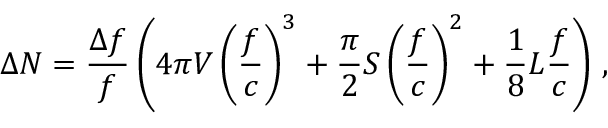<formula> <loc_0><loc_0><loc_500><loc_500>\Delta N = \frac { \Delta f } { f } \left ( 4 \pi V \left ( \frac { f } { c } \right ) ^ { 3 } + \frac { \pi } { 2 } S \left ( \frac { f } { c } \right ) ^ { 2 } + \frac { 1 } { 8 } L \frac { f } { c } \right ) \, ,</formula> 